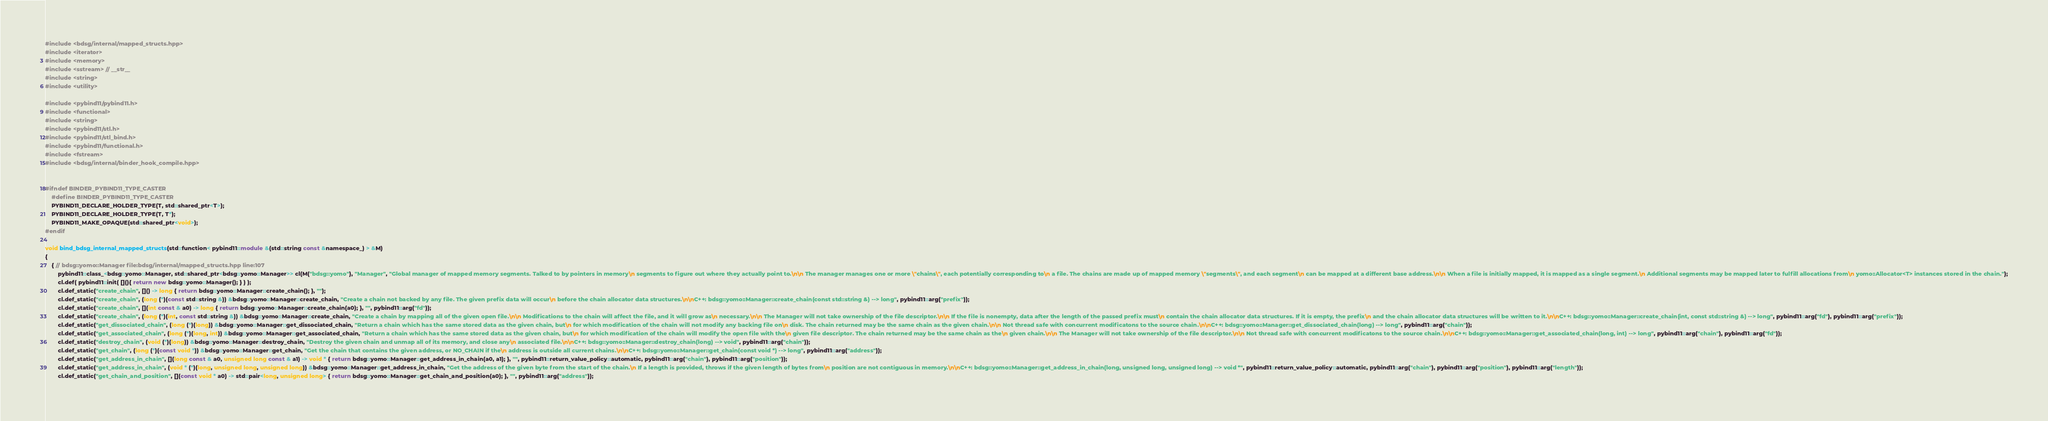Convert code to text. <code><loc_0><loc_0><loc_500><loc_500><_C++_>#include <bdsg/internal/mapped_structs.hpp>
#include <iterator>
#include <memory>
#include <sstream> // __str__
#include <string>
#include <utility>

#include <pybind11/pybind11.h>
#include <functional>
#include <string>
#include <pybind11/stl.h>
#include <pybind11/stl_bind.h>
#include <pybind11/functional.h>
#include <fstream>
#include <bdsg/internal/binder_hook_compile.hpp>


#ifndef BINDER_PYBIND11_TYPE_CASTER
	#define BINDER_PYBIND11_TYPE_CASTER
	PYBIND11_DECLARE_HOLDER_TYPE(T, std::shared_ptr<T>);
	PYBIND11_DECLARE_HOLDER_TYPE(T, T*);
	PYBIND11_MAKE_OPAQUE(std::shared_ptr<void>);
#endif

void bind_bdsg_internal_mapped_structs(std::function< pybind11::module &(std::string const &namespace_) > &M)
{
	{ // bdsg::yomo::Manager file:bdsg/internal/mapped_structs.hpp line:107
		pybind11::class_<bdsg::yomo::Manager, std::shared_ptr<bdsg::yomo::Manager>> cl(M("bdsg::yomo"), "Manager", "Global manager of mapped memory segments. Talked to by pointers in memory\n segments to figure out where they actually point to.\n\n The manager manages one or more \"chains\", each potentially corresponding to\n a file. The chains are made up of mapped memory \"segments\", and each segment\n can be mapped at a different base address.\n\n When a file is initially mapped, it is mapped as a single segment.\n Additional segments may be mapped later to fulfill allocations from\n yomo::Allocator<T> instances stored in the chain.");
		cl.def( pybind11::init( [](){ return new bdsg::yomo::Manager(); } ) );
		cl.def_static("create_chain", []() -> long { return bdsg::yomo::Manager::create_chain(); }, "");
		cl.def_static("create_chain", (long (*)(const std::string &)) &bdsg::yomo::Manager::create_chain, "Create a chain not backed by any file. The given prefix data will occur\n before the chain allocator data structures.\n\nC++: bdsg::yomo::Manager::create_chain(const std::string &) --> long", pybind11::arg("prefix"));
		cl.def_static("create_chain", [](int const & a0) -> long { return bdsg::yomo::Manager::create_chain(a0); }, "", pybind11::arg("fd"));
		cl.def_static("create_chain", (long (*)(int, const std::string &)) &bdsg::yomo::Manager::create_chain, "Create a chain by mapping all of the given open file.\n\n Modifications to the chain will affect the file, and it will grow as\n necessary.\n\n The Manager will not take ownership of the file descriptor.\n\n If the file is nonempty, data after the length of the passed prefix must\n contain the chain allocator data structures. If it is empty, the prefix\n and the chain allocator data structures will be written to it.\n\nC++: bdsg::yomo::Manager::create_chain(int, const std::string &) --> long", pybind11::arg("fd"), pybind11::arg("prefix"));
		cl.def_static("get_dissociated_chain", (long (*)(long)) &bdsg::yomo::Manager::get_dissociated_chain, "Return a chain which has the same stored data as the given chain, but\n for which modification of the chain will not modify any backing file on\n disk. The chain returned may be the same chain as the given chain.\n\n Not thread safe with concurrent modificatons to the source chain.\n\nC++: bdsg::yomo::Manager::get_dissociated_chain(long) --> long", pybind11::arg("chain"));
		cl.def_static("get_associated_chain", (long (*)(long, int)) &bdsg::yomo::Manager::get_associated_chain, "Return a chain which has the same stored data as the given chain, but\n for which modification of the chain will modify the open file with the\n given file descriptor. The chain returned may be the same chain as the\n given chain.\n\n The Manager will not take ownership of the file descriptor.\n\n Not thread safe with concurrent modificatons to the source chain.\n\nC++: bdsg::yomo::Manager::get_associated_chain(long, int) --> long", pybind11::arg("chain"), pybind11::arg("fd"));
		cl.def_static("destroy_chain", (void (*)(long)) &bdsg::yomo::Manager::destroy_chain, "Destroy the given chain and unmap all of its memory, and close any\n associated file.\n\nC++: bdsg::yomo::Manager::destroy_chain(long) --> void", pybind11::arg("chain"));
		cl.def_static("get_chain", (long (*)(const void *)) &bdsg::yomo::Manager::get_chain, "Get the chain that contains the given address, or NO_CHAIN if the\n address is outside all current chains.\n\nC++: bdsg::yomo::Manager::get_chain(const void *) --> long", pybind11::arg("address"));
		cl.def_static("get_address_in_chain", [](long const & a0, unsigned long const & a1) -> void * { return bdsg::yomo::Manager::get_address_in_chain(a0, a1); }, "", pybind11::return_value_policy::automatic, pybind11::arg("chain"), pybind11::arg("position"));
		cl.def_static("get_address_in_chain", (void * (*)(long, unsigned long, unsigned long)) &bdsg::yomo::Manager::get_address_in_chain, "Get the address of the given byte from the start of the chain.\n If a length is provided, throws if the given length of bytes from\n position are not contiguous in memory.\n\nC++: bdsg::yomo::Manager::get_address_in_chain(long, unsigned long, unsigned long) --> void *", pybind11::return_value_policy::automatic, pybind11::arg("chain"), pybind11::arg("position"), pybind11::arg("length"));
		cl.def_static("get_chain_and_position", [](const void * a0) -> std::pair<long, unsigned long> { return bdsg::yomo::Manager::get_chain_and_position(a0); }, "", pybind11::arg("address"));</code> 